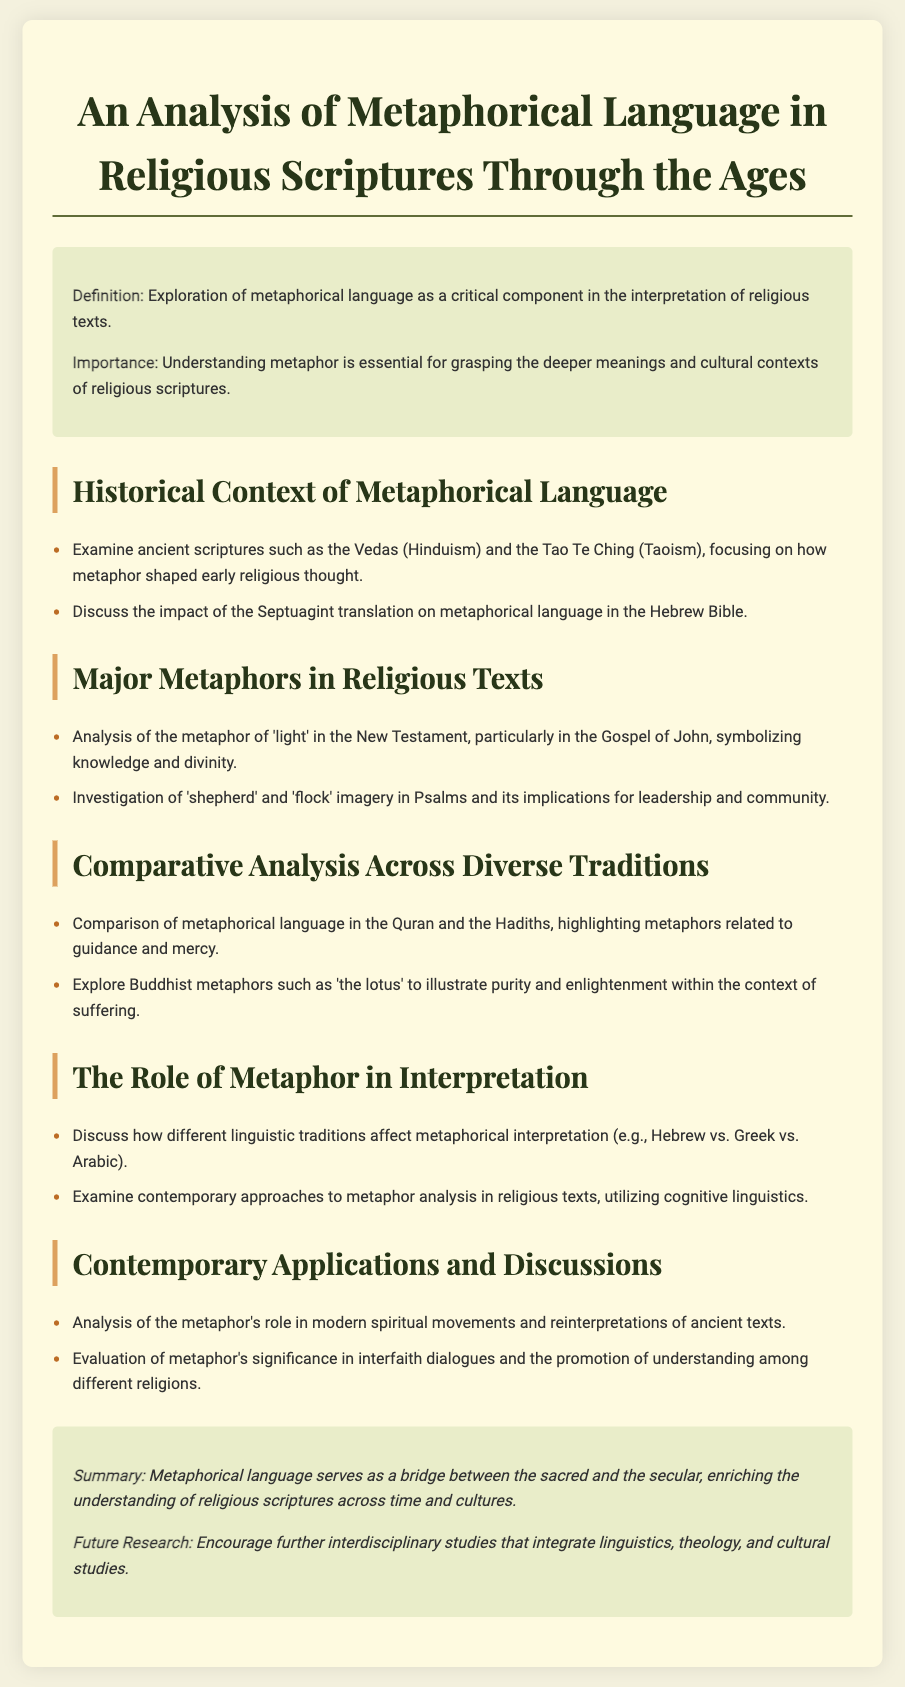What is the title of the document? The title is presented prominently at the top of the document, indicating the main focus of the content.
Answer: An Analysis of Metaphorical Language in Religious Scriptures Through the Ages What ancient scriptures are examined in the historical context section? The document lists the Vedas and the Tao Te Ching as key ancient scriptures for analysis.
Answer: Vedas and Tao Te Ching Which metaphor is analyzed in the New Testament section? The section specifically refers to the metaphor of 'light' and its significance in the Gospel of John.
Answer: 'light' What imagery is investigated in the Psalms? The document mentions 'shepherd' and 'flock' imagery related to community and leadership in Psalms.
Answer: 'shepherd' and 'flock' What is compared in the comparative analysis section? This part of the document highlights the differences in metaphorical language across the Quran and Hadiths.
Answer: metaphorical language in the Quran and Hadiths Which Buddhist metaphor is discussed? The document points out the 'lotus' metaphor as illustrating purity and enlightenment.
Answer: 'the lotus' What impact does linguistic tradition have in interpretation? The document discusses the influence of different linguistic backgrounds on metaphorical interpretation, specifically naming Hebrew, Greek, and Arabic.
Answer: Hebrew, Greek, Arabic What is encouraged for future research? The document suggests further interdisciplinary studies combining various fields such as linguistics and theology.
Answer: interdisciplinary studies 